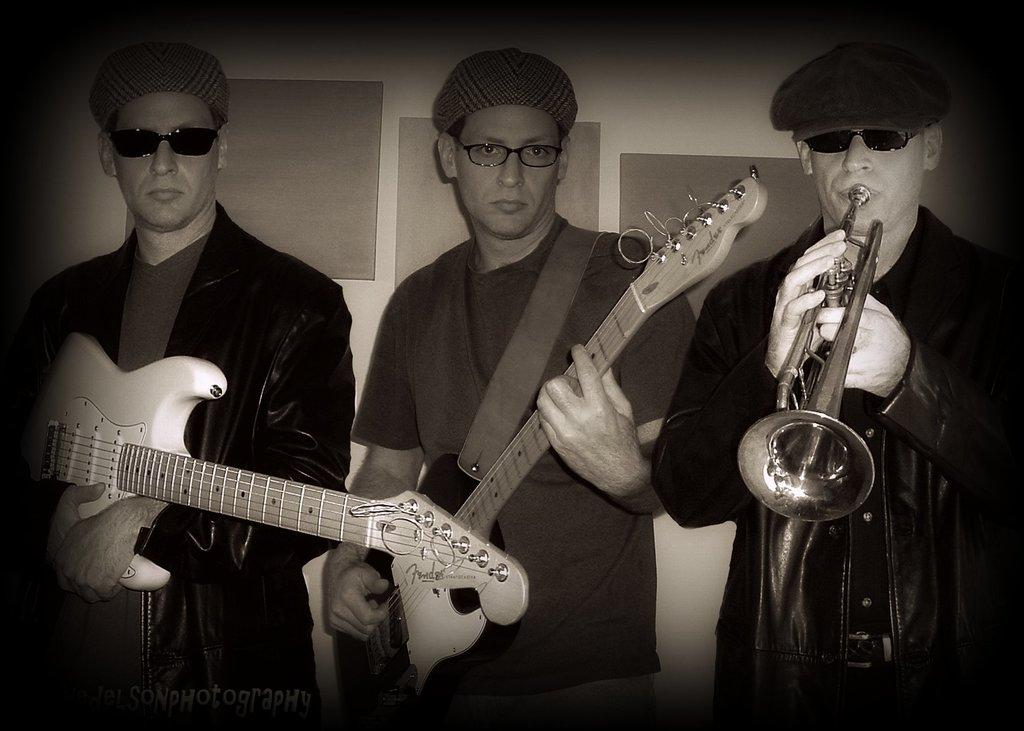How many people are in the image? There are three men in the image. What are two of the men doing in the image? Two of the men are holding guitars and playing them. What is the third man doing in the image? The third man is playing a musical instrument. What can be seen in the background of the image? There is a wall in the background of the image. What type of car can be seen in the image? There is no car present in the image. What kind of trail is visible in the image? There is no trail visible in the image. 